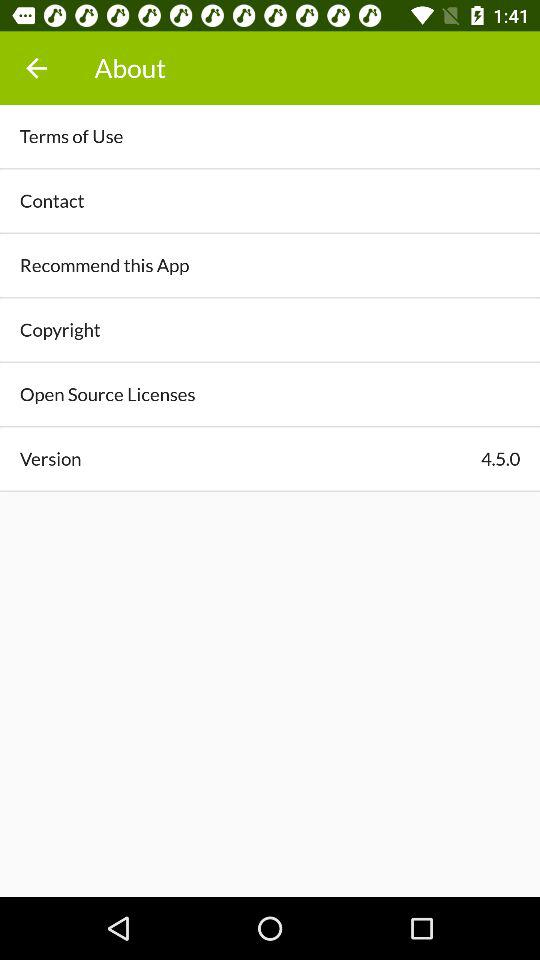How many people recommend this application?
When the provided information is insufficient, respond with <no answer>. <no answer> 